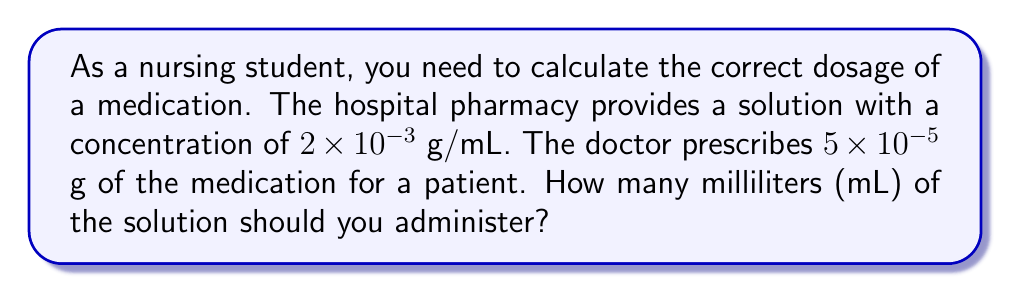Help me with this question. Let's approach this step-by-step:

1) We know:
   - Concentration of solution: $2 \times 10^{-3}$ g/mL
   - Prescribed dose: $5 \times 10^{-5}$ g

2) To find the volume (V) in mL, we use the formula:
   $V = \frac{\text{Prescribed dose}}{\text{Concentration}}$

3) Substituting the values:
   $V = \frac{5 \times 10^{-5}}{2 \times 10^{-3}}$

4) To divide these numbers with exponents:
   - Divide the coefficients: $\frac{5}{2} = 2.5$
   - Subtract the exponents: $-5 - (-3) = -2$

5) Therefore:
   $V = 2.5 \times 10^{-2}$ mL

6) Converting to a more practical unit:
   $2.5 \times 10^{-2}$ mL $= 0.025$ mL

This is equivalent to 0.025 mL or 25 microliters (μL).
Answer: $0.025$ mL 